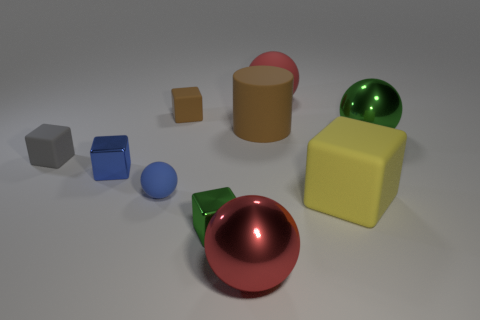Is the number of big yellow things that are right of the green sphere less than the number of green balls? No, the number of big yellow things to the right of the green sphere is equal to the number of green balls, which is one. 